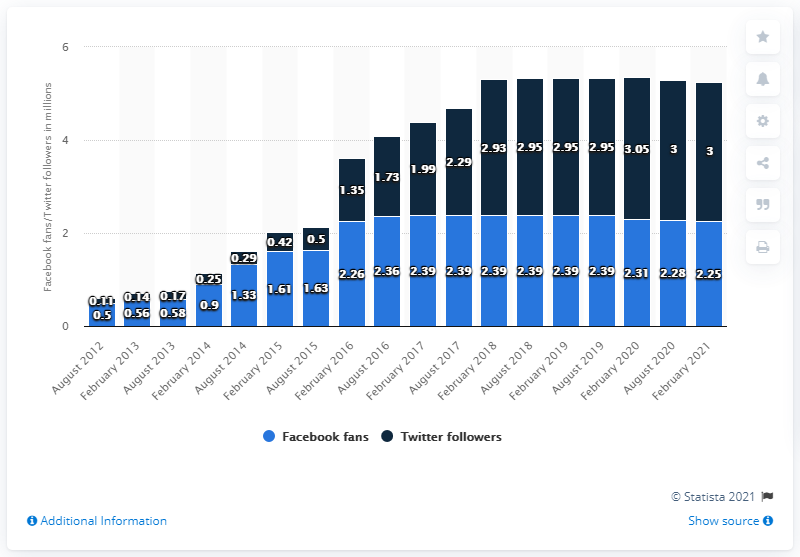Specify some key components in this picture. The Facebook page of the Carolina Panthers ended in February 2021. The Carolina Panthers' Facebook page was created in August 2012. 